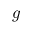Convert formula to latex. <formula><loc_0><loc_0><loc_500><loc_500>g</formula> 